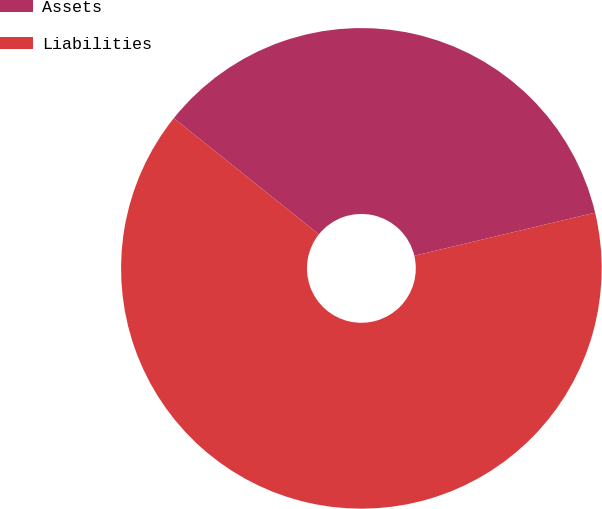<chart> <loc_0><loc_0><loc_500><loc_500><pie_chart><fcel>Assets<fcel>Liabilities<nl><fcel>35.53%<fcel>64.47%<nl></chart> 